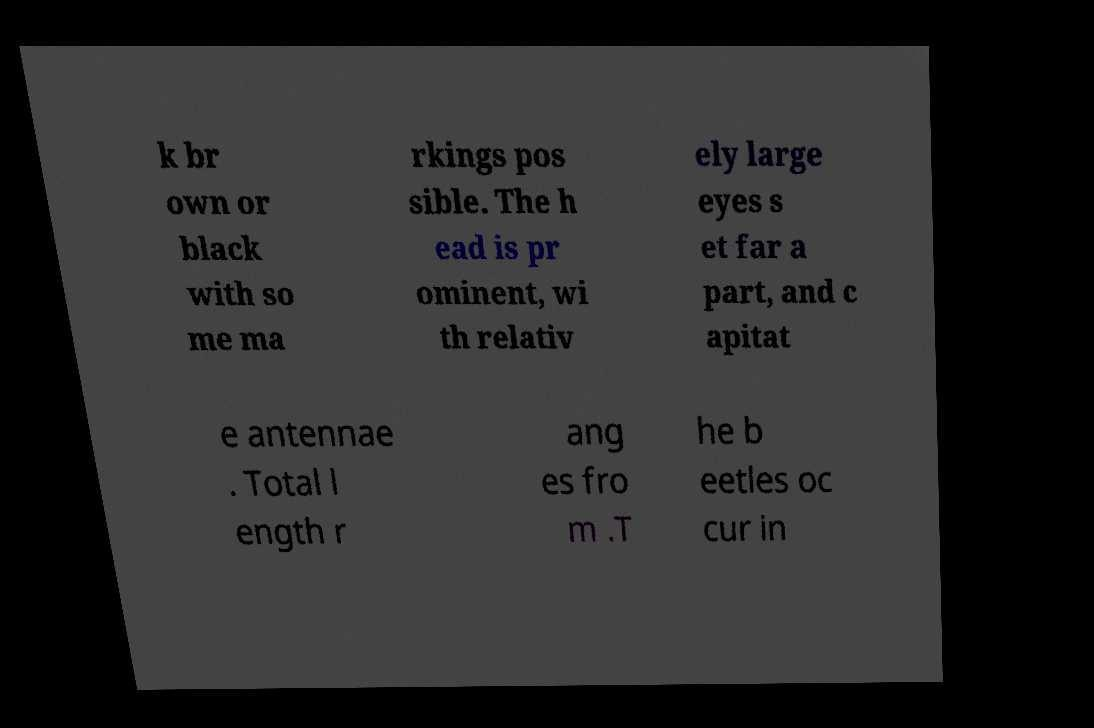Can you accurately transcribe the text from the provided image for me? k br own or black with so me ma rkings pos sible. The h ead is pr ominent, wi th relativ ely large eyes s et far a part, and c apitat e antennae . Total l ength r ang es fro m .T he b eetles oc cur in 